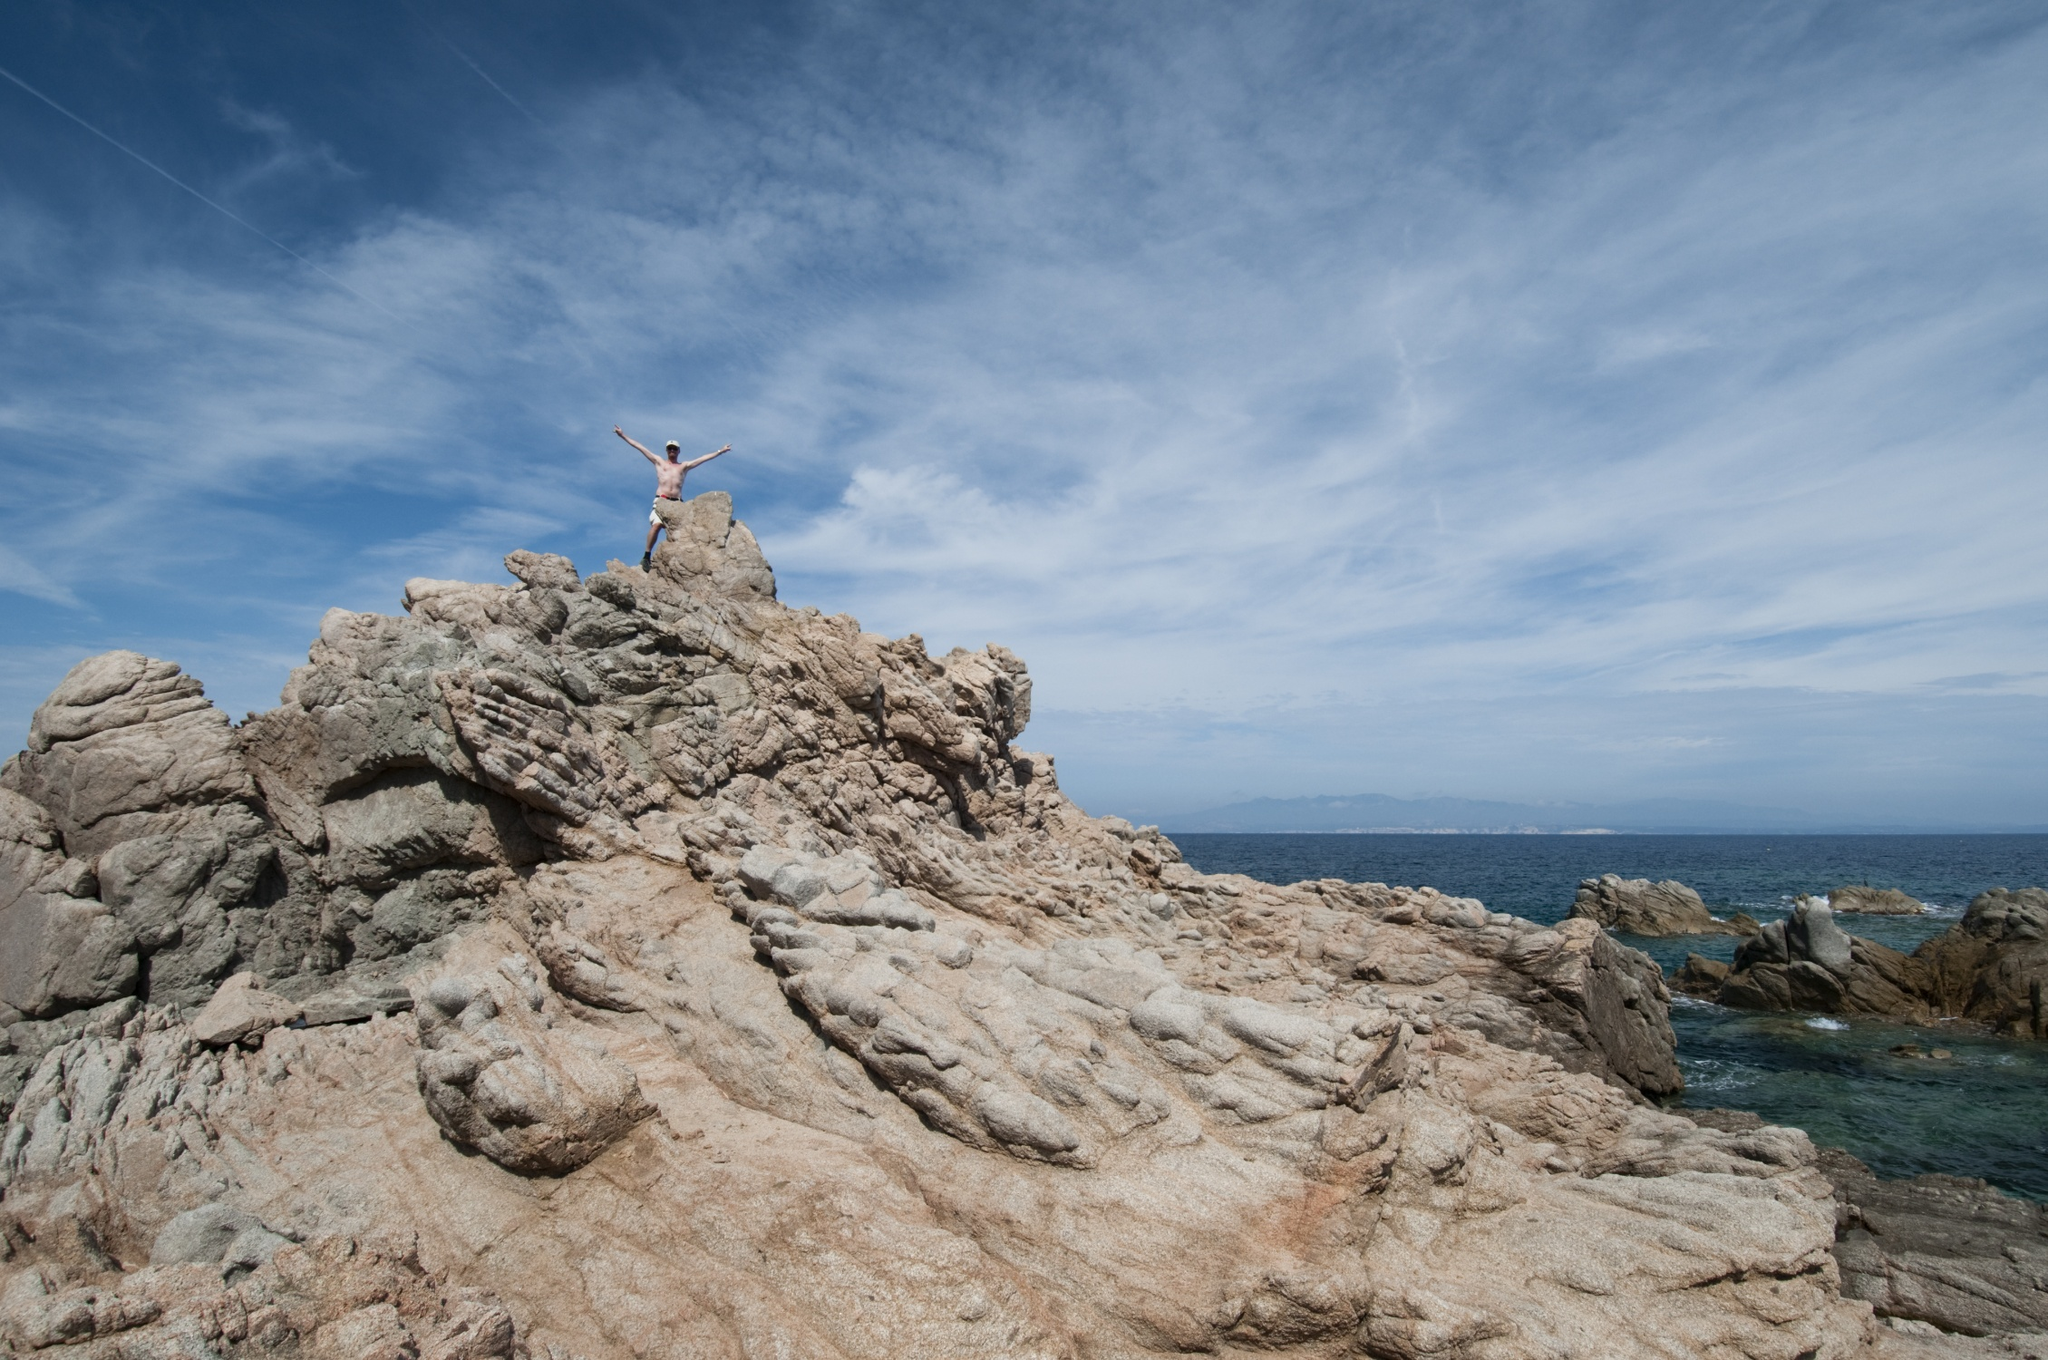Can you describe the feelings or emotions that this image might evoke? This image evokes a sense of triumph and exhilaration, capturing the joyous spirit of achievement as the person stands with arms outstretched against a backdrop of vast, open sky and ocean. There's a feeling of freedom and boundless possibility, as if the individual is celebrating a hard-won victory or reveling in the sheer beauty of nature. The serene sky and the endless ocean add a layer of tranquility, balancing the emotional high with a soothing calm. 